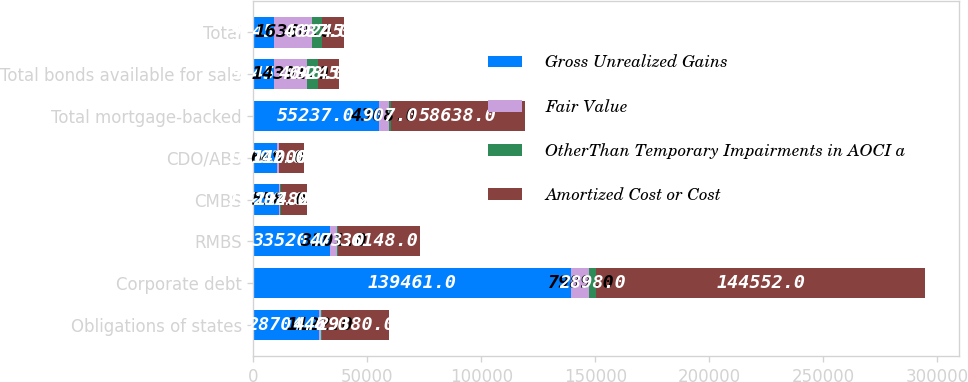Convert chart to OTSL. <chart><loc_0><loc_0><loc_500><loc_500><stacked_bar_chart><ecel><fcel>Obligations of states<fcel>Corporate debt<fcel>RMBS<fcel>CMBS<fcel>CDO/ABS<fcel>Total mortgage-backed<fcel>Total bonds available for sale<fcel>Total<nl><fcel>Gross Unrealized Gains<fcel>28704<fcel>139461<fcel>33520<fcel>11216<fcel>10501<fcel>55237<fcel>9245<fcel>9245<nl><fcel>Fair Value<fcel>1122<fcel>7989<fcel>3101<fcel>558<fcel>649<fcel>4308<fcel>14391<fcel>16360<nl><fcel>OtherThan Temporary Impairments in AOCI a<fcel>446<fcel>2898<fcel>473<fcel>292<fcel>142<fcel>907<fcel>4648<fcel>4687<nl><fcel>Amortized Cost or Cost<fcel>29380<fcel>144552<fcel>36148<fcel>11482<fcel>11008<fcel>58638<fcel>9245<fcel>9245<nl></chart> 